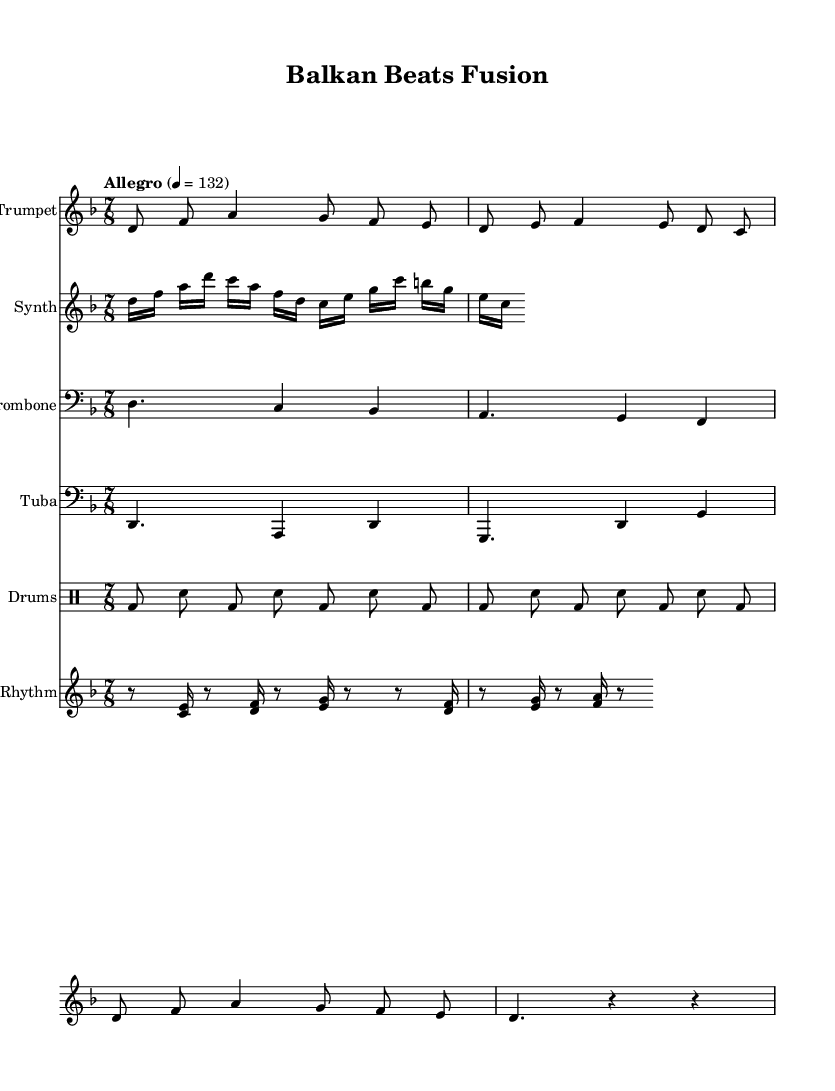What is the key signature of this music? The key signature is D minor, indicated by one flat (B flat). The key signature is typically presented at the beginning of the staff.
Answer: D minor What is the time signature of the piece? The time signature is 7/8, shown prominently at the beginning of the score after the key signature. This indicates there are 7 beats in each measure, with each beat corresponding to an eighth note.
Answer: 7/8 What is the tempo marking of the composition? The tempo marking is "Allegro" with a metronome marking of 132 beats per minute, indicating that the piece should be played at a quick pace. This marking is located at the beginning of the score above the staff.
Answer: Allegro, 132 How many instruments are specified in the score? The score includes five distinct instruments: Trumpet, Synth, Trombone, Tuba, and Drums. Each instrument is represented on a separate staff that labels the instrument name.
Answer: Five Which two instruments play together in the same rhythm section? The Drum staff and Synth Rhythm staff play together in a coordinated rhythmic style, emphasizing the electronic-feel of the fusion music. The drum patterns and the synthesizer rhythms interact to create a dynamic texture.
Answer: Drum and Synth Rhythm What type of musical fusion is being represented in this piece? This composition represents a fusion of Balkan brass band traditional music with modern electronic beats. The instrumentation and rhythmic complexity reflect the cultural intersections typical of such fusions.
Answer: Balkan brass and electronic beats 